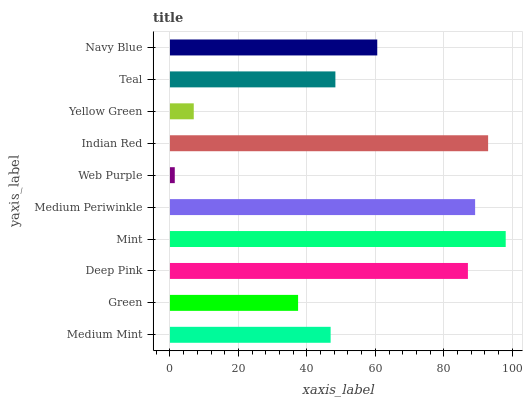Is Web Purple the minimum?
Answer yes or no. Yes. Is Mint the maximum?
Answer yes or no. Yes. Is Green the minimum?
Answer yes or no. No. Is Green the maximum?
Answer yes or no. No. Is Medium Mint greater than Green?
Answer yes or no. Yes. Is Green less than Medium Mint?
Answer yes or no. Yes. Is Green greater than Medium Mint?
Answer yes or no. No. Is Medium Mint less than Green?
Answer yes or no. No. Is Navy Blue the high median?
Answer yes or no. Yes. Is Teal the low median?
Answer yes or no. Yes. Is Yellow Green the high median?
Answer yes or no. No. Is Deep Pink the low median?
Answer yes or no. No. 